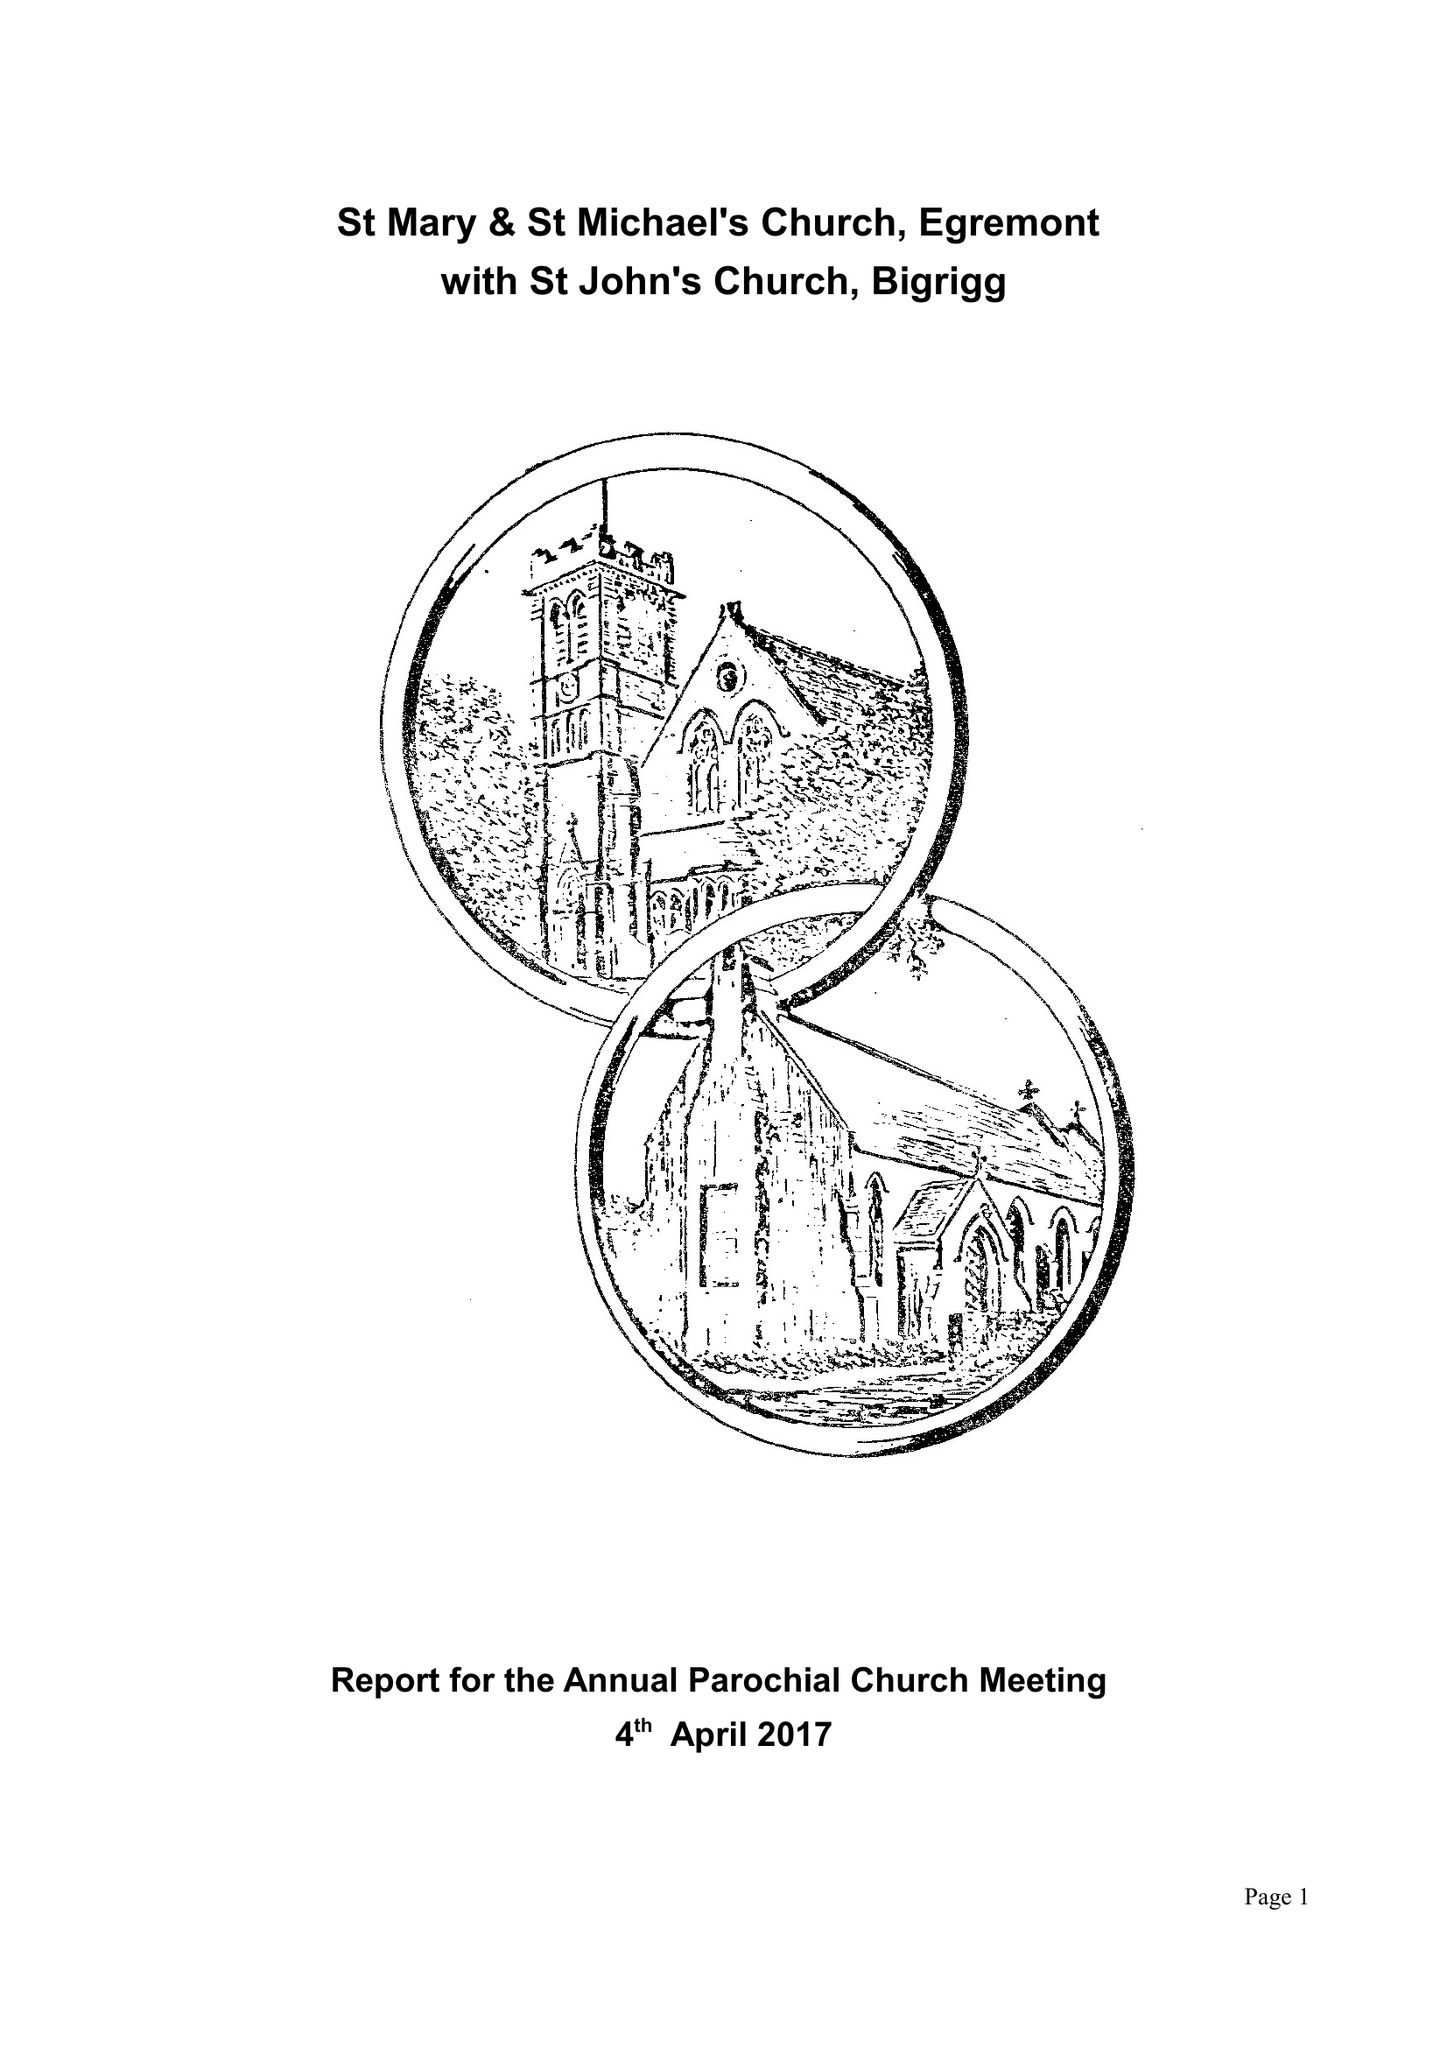What is the value for the address__postcode?
Answer the question using a single word or phrase. CA22 2EH 